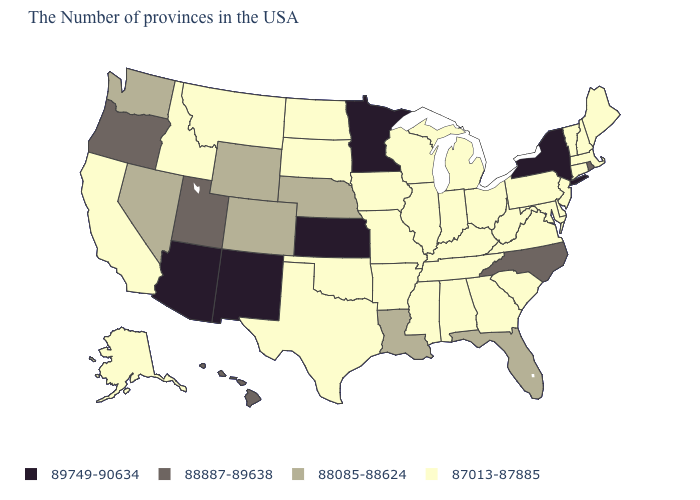What is the lowest value in states that border Tennessee?
Answer briefly. 87013-87885. Name the states that have a value in the range 88085-88624?
Give a very brief answer. Florida, Louisiana, Nebraska, Wyoming, Colorado, Nevada, Washington. What is the value of Massachusetts?
Write a very short answer. 87013-87885. What is the value of Mississippi?
Be succinct. 87013-87885. What is the value of South Carolina?
Keep it brief. 87013-87885. Does Wyoming have a higher value than Alaska?
Short answer required. Yes. Does Oregon have the same value as Rhode Island?
Give a very brief answer. Yes. Which states have the highest value in the USA?
Concise answer only. New York, Minnesota, Kansas, New Mexico, Arizona. Name the states that have a value in the range 87013-87885?
Short answer required. Maine, Massachusetts, New Hampshire, Vermont, Connecticut, New Jersey, Delaware, Maryland, Pennsylvania, Virginia, South Carolina, West Virginia, Ohio, Georgia, Michigan, Kentucky, Indiana, Alabama, Tennessee, Wisconsin, Illinois, Mississippi, Missouri, Arkansas, Iowa, Oklahoma, Texas, South Dakota, North Dakota, Montana, Idaho, California, Alaska. Does Hawaii have the same value as Rhode Island?
Give a very brief answer. Yes. What is the value of Arkansas?
Write a very short answer. 87013-87885. Name the states that have a value in the range 87013-87885?
Give a very brief answer. Maine, Massachusetts, New Hampshire, Vermont, Connecticut, New Jersey, Delaware, Maryland, Pennsylvania, Virginia, South Carolina, West Virginia, Ohio, Georgia, Michigan, Kentucky, Indiana, Alabama, Tennessee, Wisconsin, Illinois, Mississippi, Missouri, Arkansas, Iowa, Oklahoma, Texas, South Dakota, North Dakota, Montana, Idaho, California, Alaska. Does Minnesota have the highest value in the USA?
Concise answer only. Yes. What is the lowest value in states that border North Dakota?
Give a very brief answer. 87013-87885. Name the states that have a value in the range 88085-88624?
Concise answer only. Florida, Louisiana, Nebraska, Wyoming, Colorado, Nevada, Washington. 